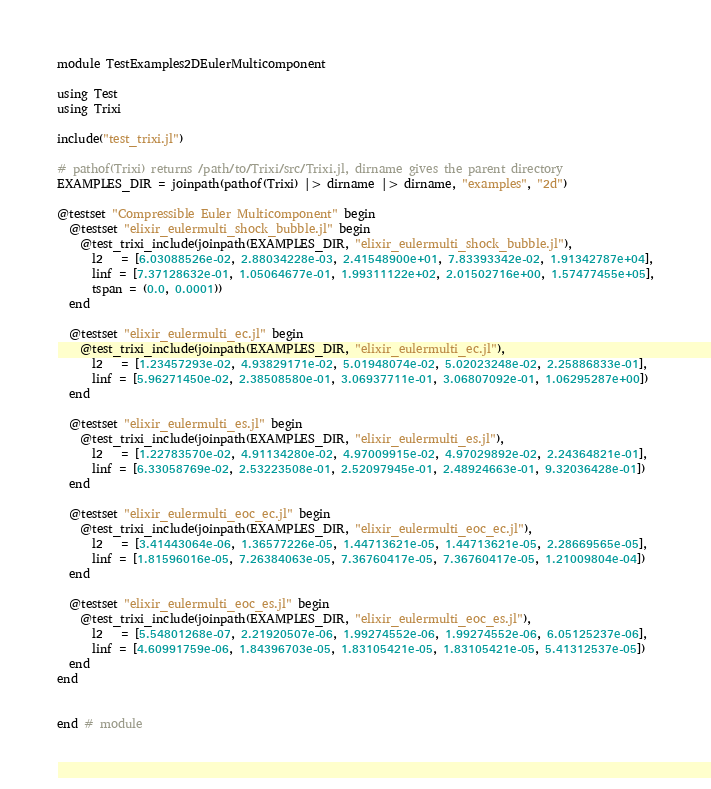Convert code to text. <code><loc_0><loc_0><loc_500><loc_500><_Julia_>module TestExamples2DEulerMulticomponent

using Test
using Trixi

include("test_trixi.jl")

# pathof(Trixi) returns /path/to/Trixi/src/Trixi.jl, dirname gives the parent directory
EXAMPLES_DIR = joinpath(pathof(Trixi) |> dirname |> dirname, "examples", "2d")

@testset "Compressible Euler Multicomponent" begin
  @testset "elixir_eulermulti_shock_bubble.jl" begin
    @test_trixi_include(joinpath(EXAMPLES_DIR, "elixir_eulermulti_shock_bubble.jl"),
      l2   = [6.03088526e-02, 2.88034228e-03, 2.41548900e+01, 7.83393342e-02, 1.91342787e+04],
      linf = [7.37128632e-01, 1.05064677e-01, 1.99311122e+02, 2.01502716e+00, 1.57477455e+05],
      tspan = (0.0, 0.0001))
  end

  @testset "elixir_eulermulti_ec.jl" begin
    @test_trixi_include(joinpath(EXAMPLES_DIR, "elixir_eulermulti_ec.jl"),
      l2   = [1.23457293e-02, 4.93829171e-02, 5.01948074e-02, 5.02023248e-02, 2.25886833e-01],
      linf = [5.96271450e-02, 2.38508580e-01, 3.06937711e-01, 3.06807092e-01, 1.06295287e+00])
  end

  @testset "elixir_eulermulti_es.jl" begin
    @test_trixi_include(joinpath(EXAMPLES_DIR, "elixir_eulermulti_es.jl"),
      l2   = [1.22783570e-02, 4.91134280e-02, 4.97009915e-02, 4.97029892e-02, 2.24364821e-01],
      linf = [6.33058769e-02, 2.53223508e-01, 2.52097945e-01, 2.48924663e-01, 9.32036428e-01])
  end

  @testset "elixir_eulermulti_eoc_ec.jl" begin
    @test_trixi_include(joinpath(EXAMPLES_DIR, "elixir_eulermulti_eoc_ec.jl"),
      l2   = [3.41443064e-06, 1.36577226e-05, 1.44713621e-05, 1.44713621e-05, 2.28669565e-05],
      linf = [1.81596016e-05, 7.26384063e-05, 7.36760417e-05, 7.36760417e-05, 1.21009804e-04])
  end

  @testset "elixir_eulermulti_eoc_es.jl" begin
    @test_trixi_include(joinpath(EXAMPLES_DIR, "elixir_eulermulti_eoc_es.jl"),
      l2   = [5.54801268e-07, 2.21920507e-06, 1.99274552e-06, 1.99274552e-06, 6.05125237e-06],
      linf = [4.60991759e-06, 1.84396703e-05, 1.83105421e-05, 1.83105421e-05, 5.41312537e-05])
  end
end


end # module
</code> 